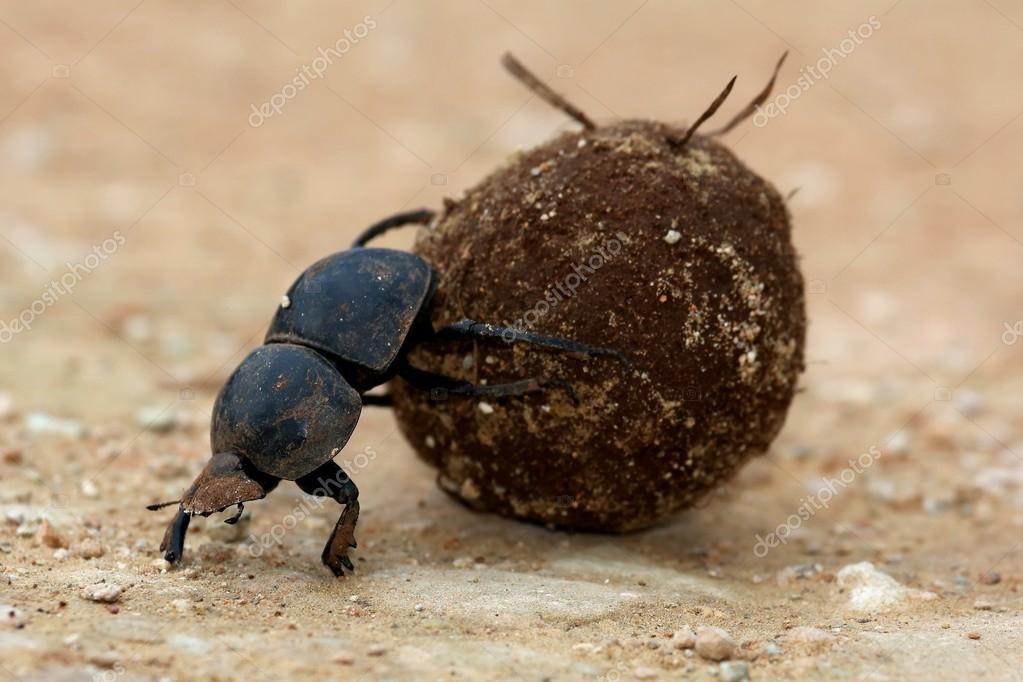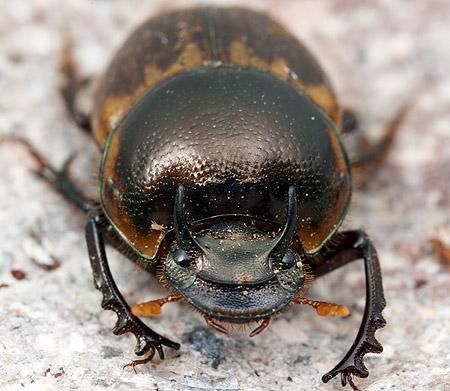The first image is the image on the left, the second image is the image on the right. For the images shown, is this caption "One image does not include a dungball with the beetle." true? Answer yes or no. Yes. 